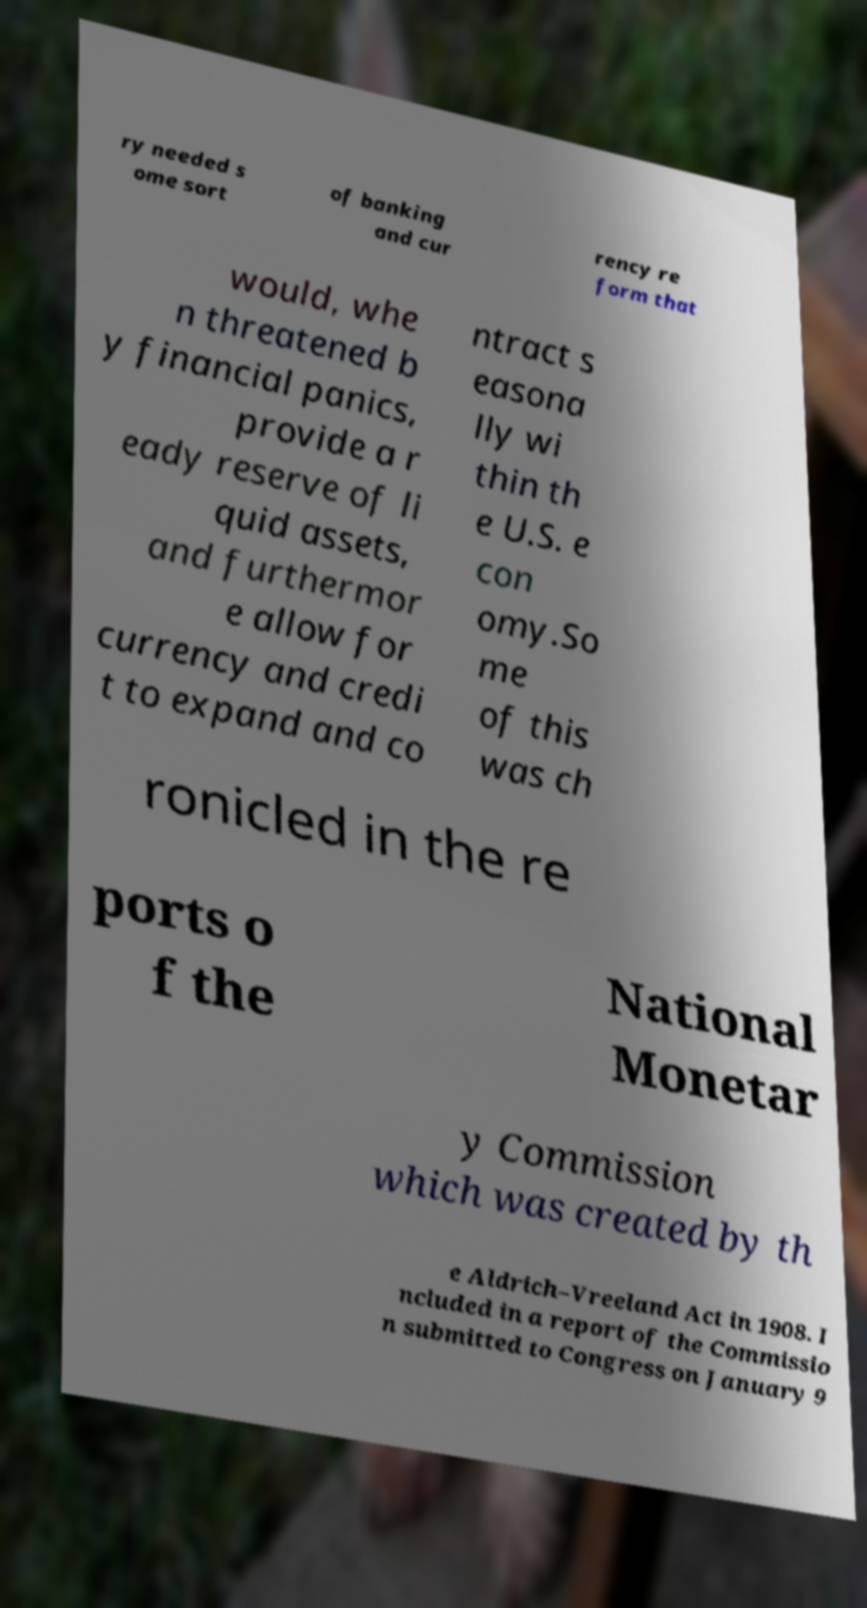Could you assist in decoding the text presented in this image and type it out clearly? ry needed s ome sort of banking and cur rency re form that would, whe n threatened b y financial panics, provide a r eady reserve of li quid assets, and furthermor e allow for currency and credi t to expand and co ntract s easona lly wi thin th e U.S. e con omy.So me of this was ch ronicled in the re ports o f the National Monetar y Commission which was created by th e Aldrich–Vreeland Act in 1908. I ncluded in a report of the Commissio n submitted to Congress on January 9 